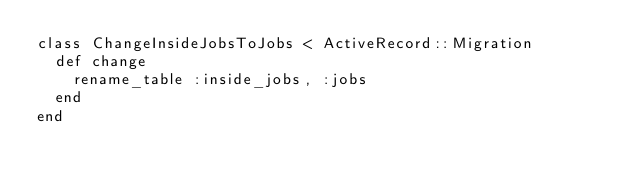Convert code to text. <code><loc_0><loc_0><loc_500><loc_500><_Ruby_>class ChangeInsideJobsToJobs < ActiveRecord::Migration
  def change
  	rename_table :inside_jobs, :jobs
  end
end
</code> 